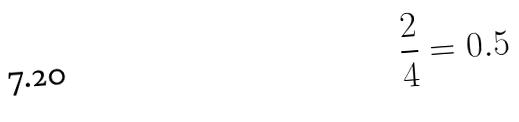<formula> <loc_0><loc_0><loc_500><loc_500>\frac { 2 } { 4 } = 0 . 5</formula> 